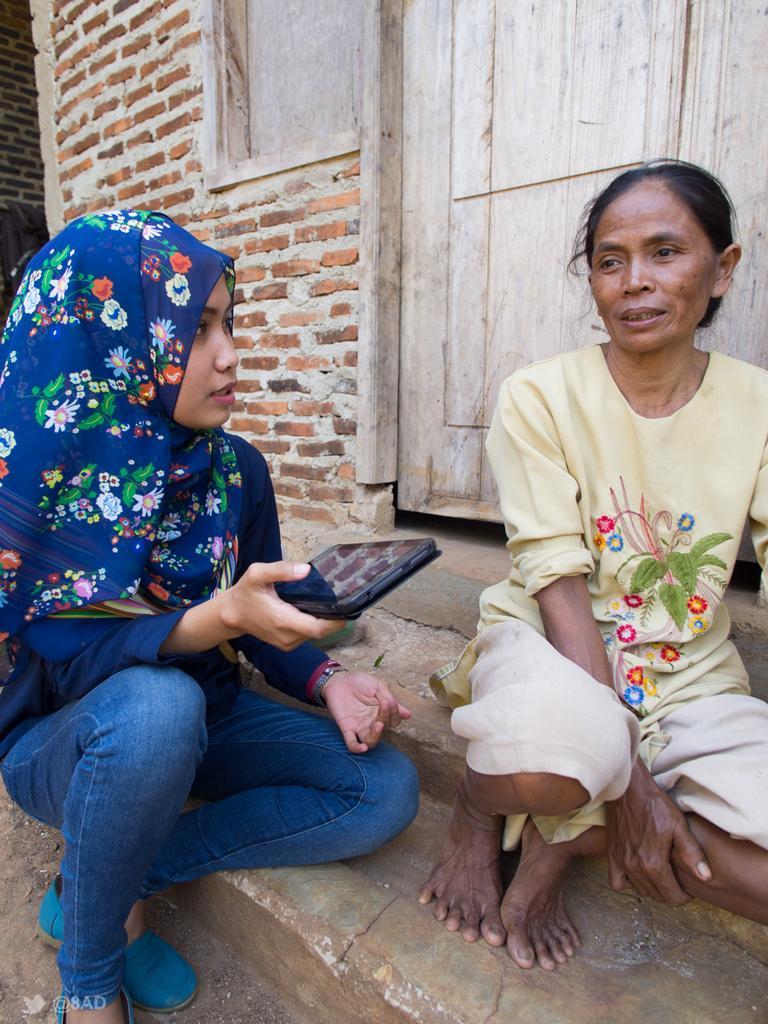Please provide a concise description of this image. There are two women sitting on surface and this woman holding tab. On the background we can see wall and wooden door. 